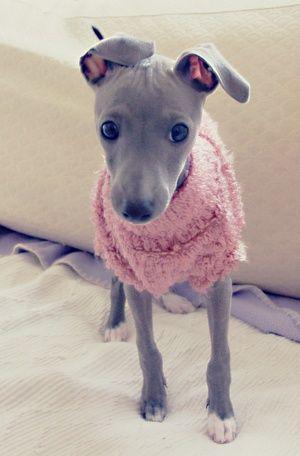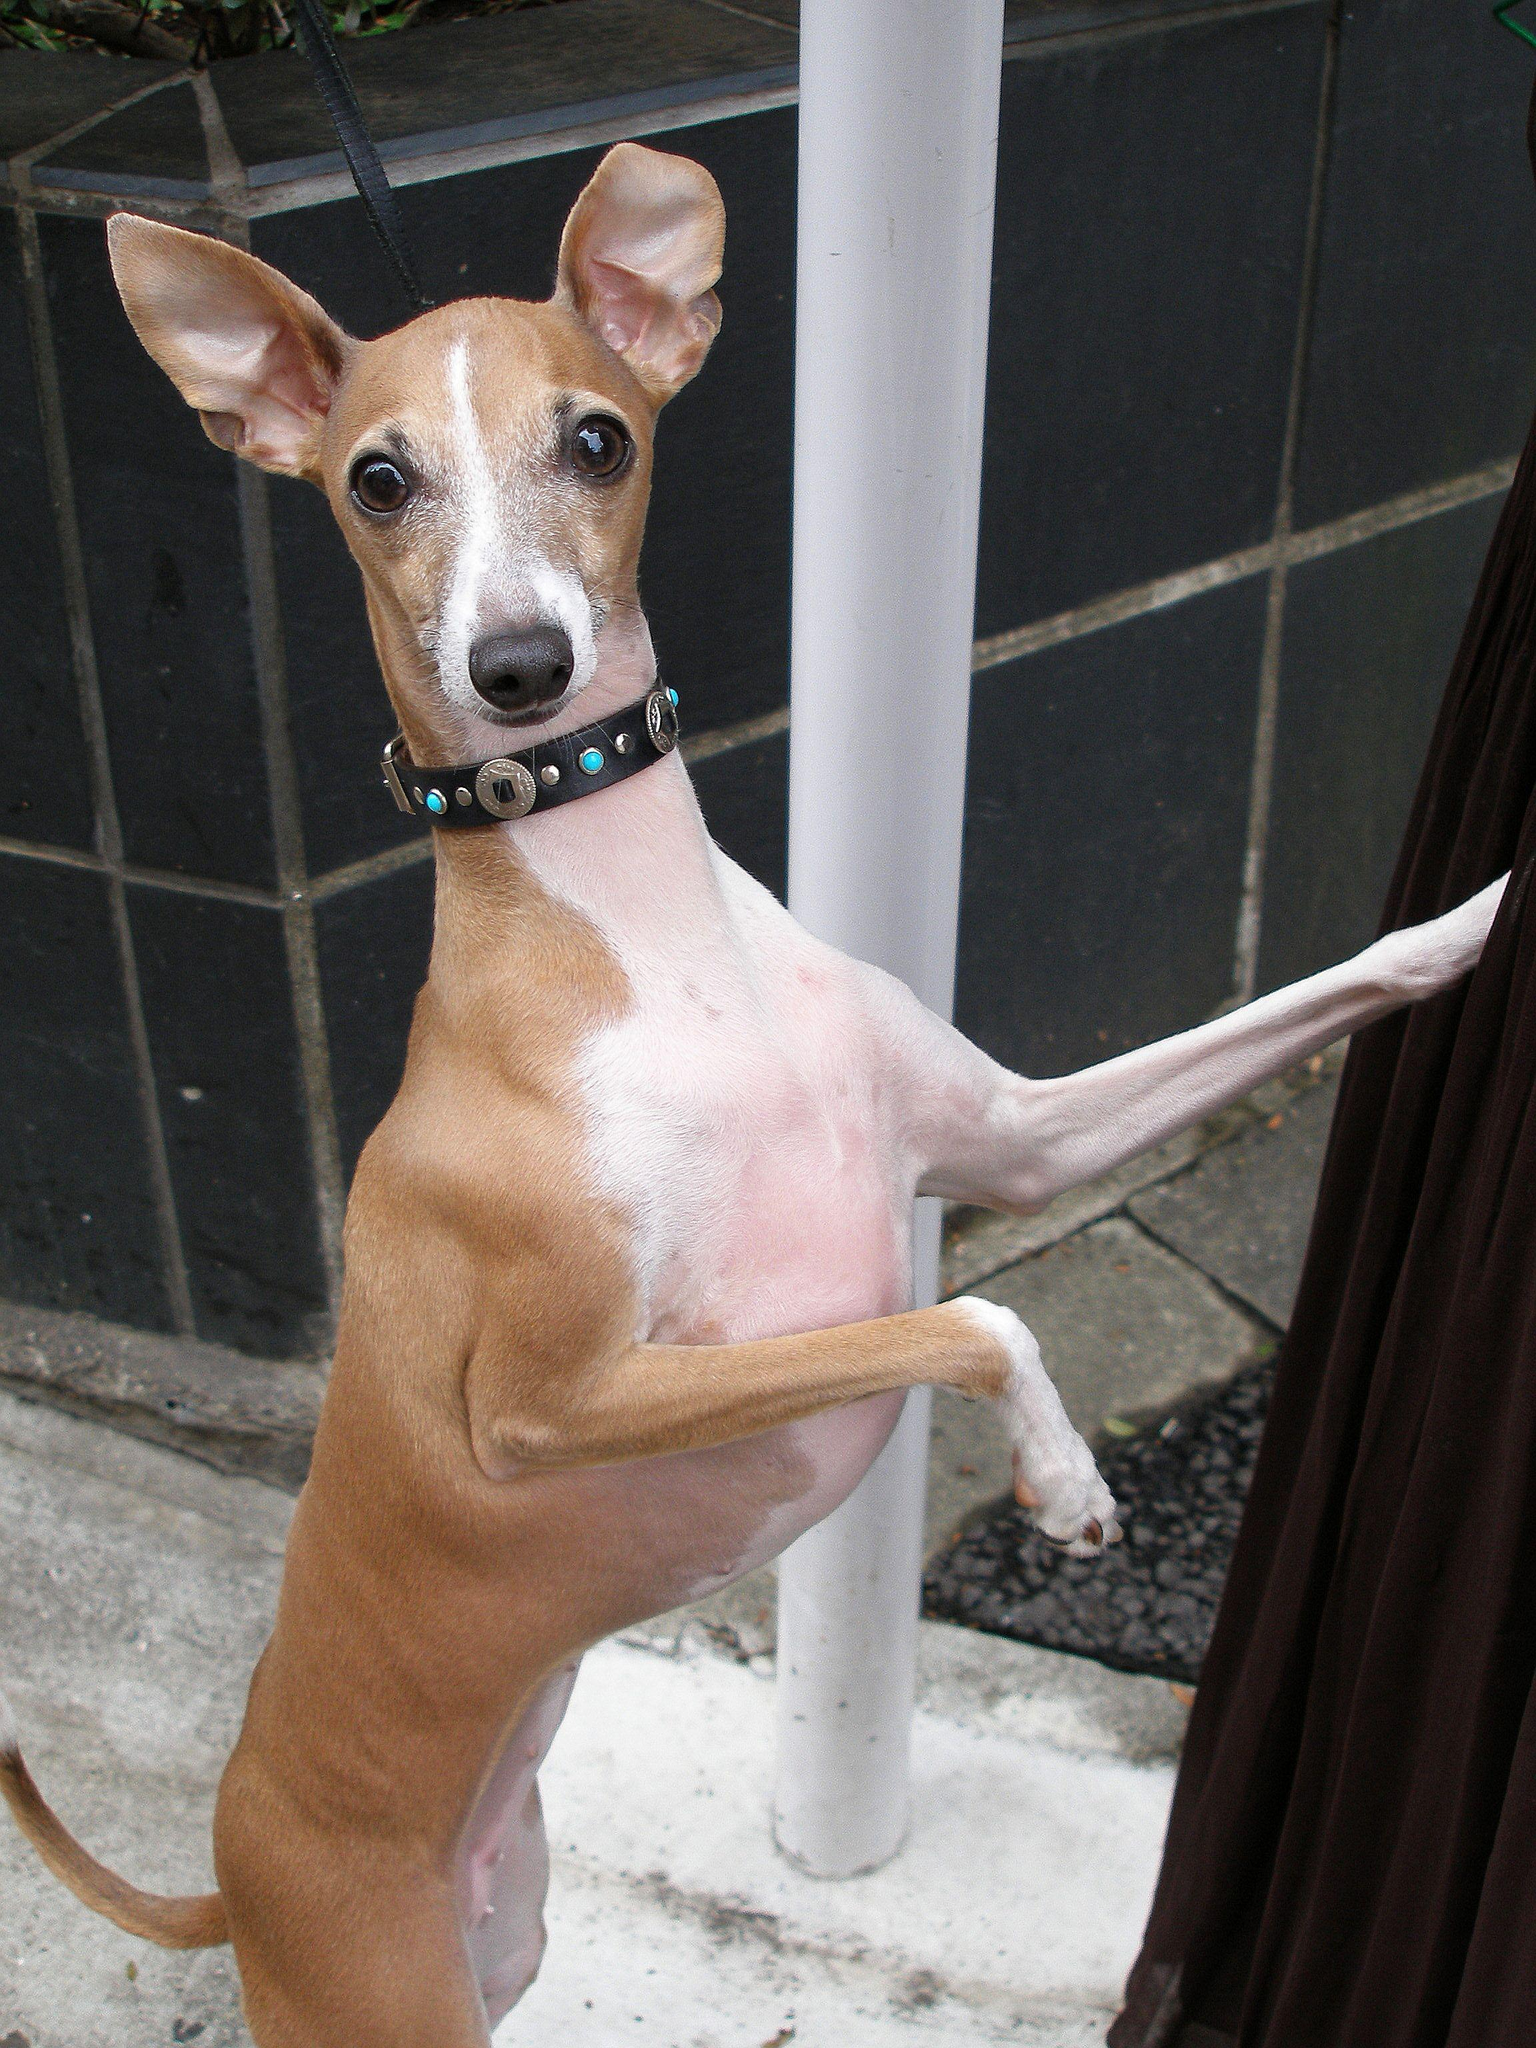The first image is the image on the left, the second image is the image on the right. Analyze the images presented: Is the assertion "At least one dog is sitting." valid? Answer yes or no. No. The first image is the image on the left, the second image is the image on the right. Examine the images to the left and right. Is the description "In the left image, there's an Italian Greyhound wearing a sweater and sitting." accurate? Answer yes or no. No. 